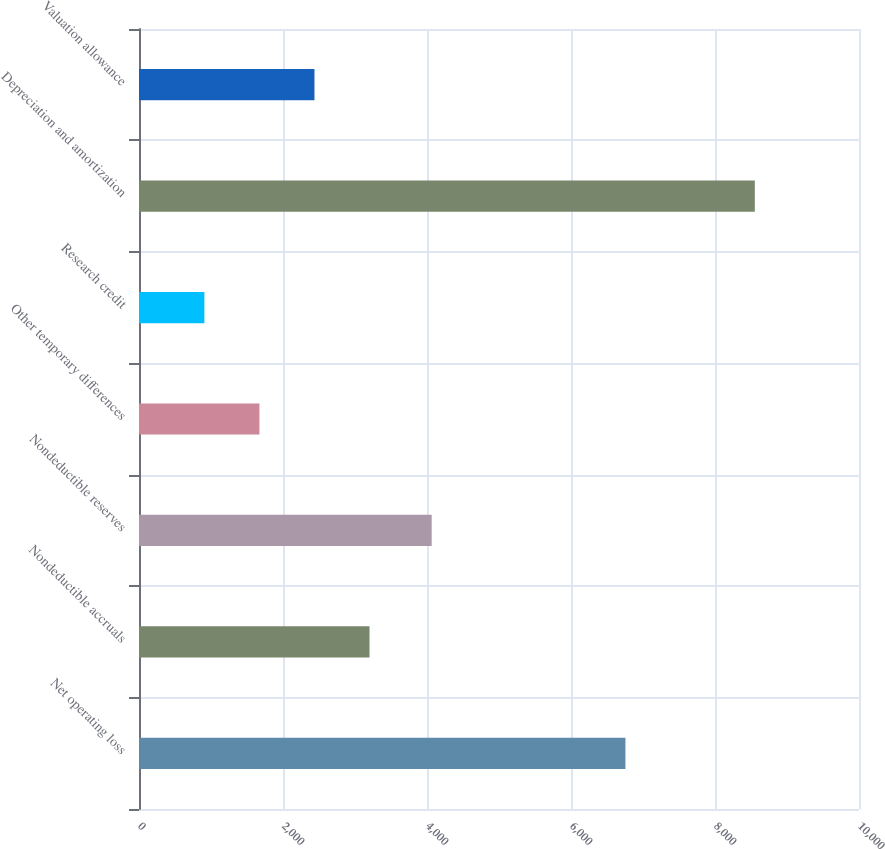<chart> <loc_0><loc_0><loc_500><loc_500><bar_chart><fcel>Net operating loss<fcel>Nondeductible accruals<fcel>Nondeductible reserves<fcel>Other temporary differences<fcel>Research credit<fcel>Depreciation and amortization<fcel>Valuation allowance<nl><fcel>6756<fcel>3201.5<fcel>4065<fcel>1672.5<fcel>908<fcel>8553<fcel>2437<nl></chart> 